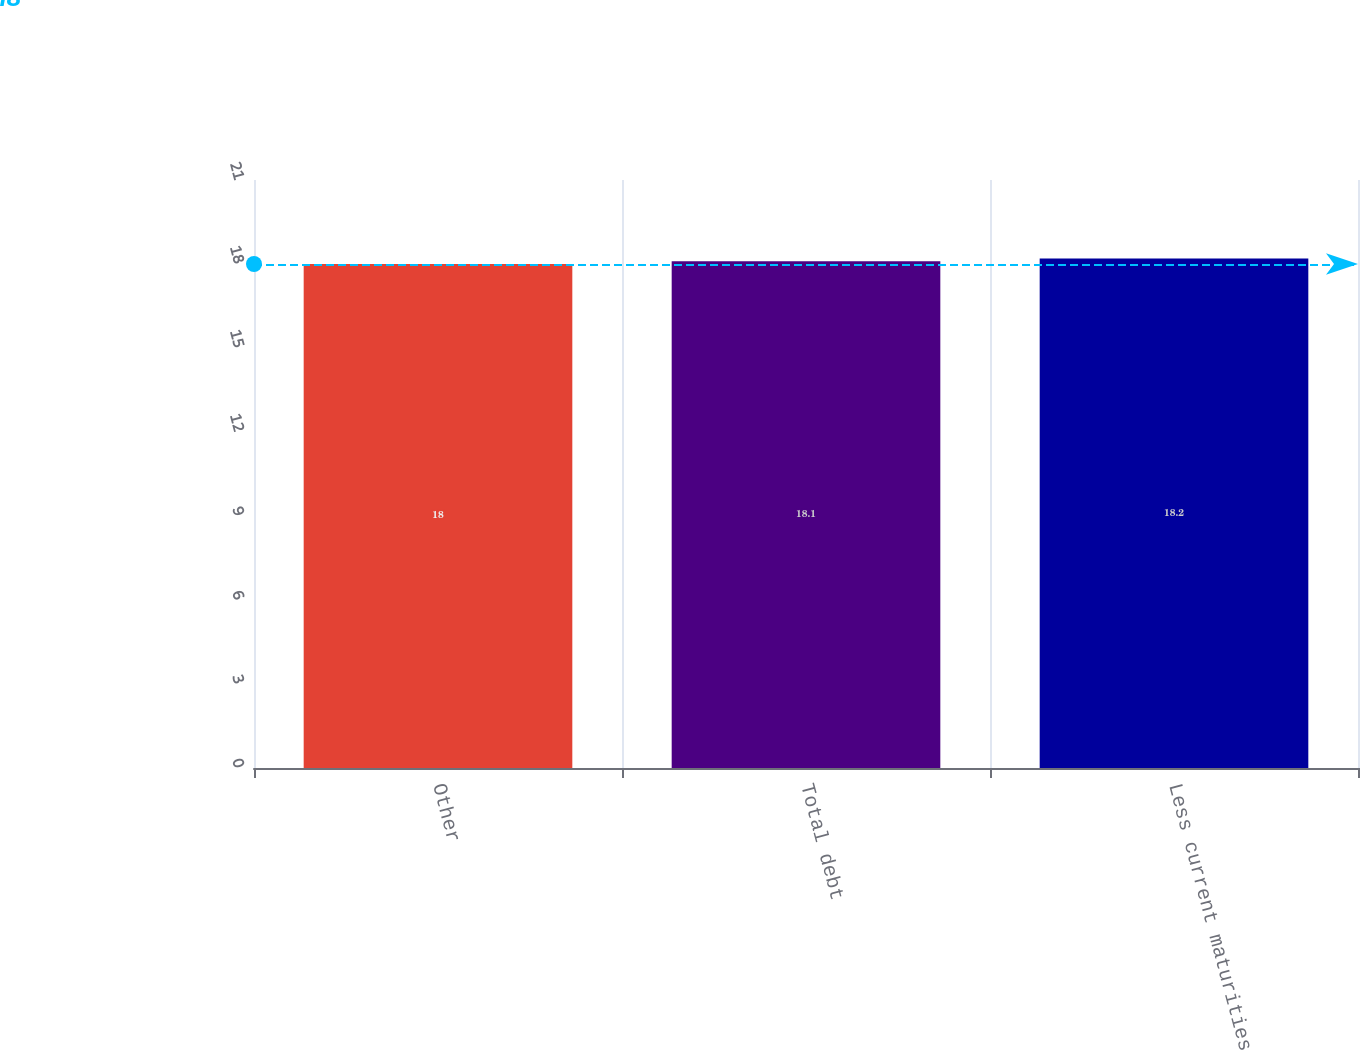<chart> <loc_0><loc_0><loc_500><loc_500><bar_chart><fcel>Other<fcel>Total debt<fcel>Less current maturities<nl><fcel>18<fcel>18.1<fcel>18.2<nl></chart> 